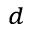<formula> <loc_0><loc_0><loc_500><loc_500>^ { d }</formula> 